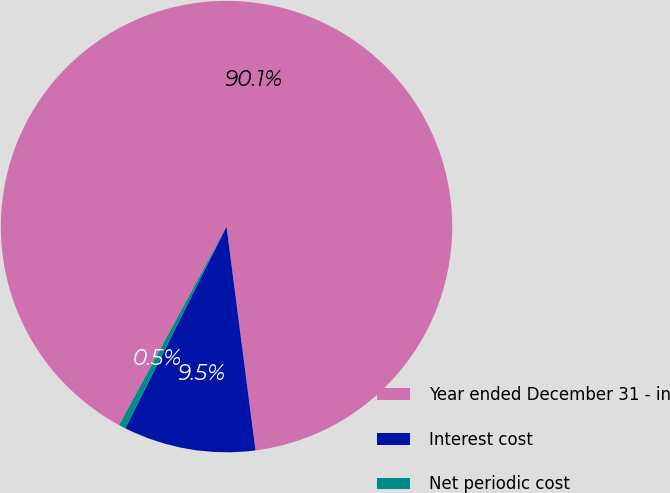Convert chart to OTSL. <chart><loc_0><loc_0><loc_500><loc_500><pie_chart><fcel>Year ended December 31 - in<fcel>Interest cost<fcel>Net periodic cost<nl><fcel>90.06%<fcel>9.45%<fcel>0.49%<nl></chart> 